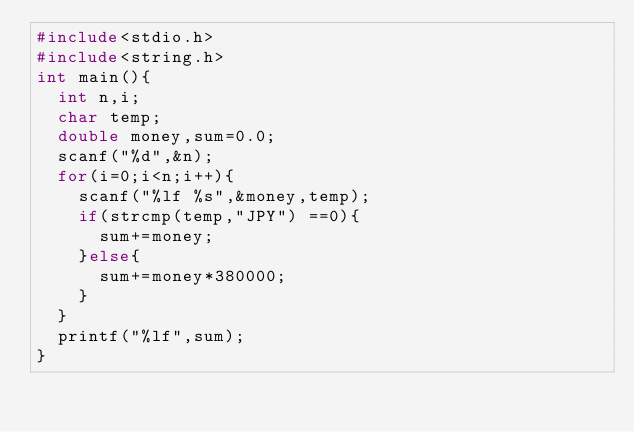Convert code to text. <code><loc_0><loc_0><loc_500><loc_500><_C_>#include<stdio.h>
#include<string.h>
int main(){
  int n,i;
  char temp;
  double money,sum=0.0;
  scanf("%d",&n);
  for(i=0;i<n;i++){
    scanf("%lf %s",&money,temp);
    if(strcmp(temp,"JPY") ==0){
      sum+=money;
    }else{
      sum+=money*380000;
    }
  }
  printf("%lf",sum);
}</code> 